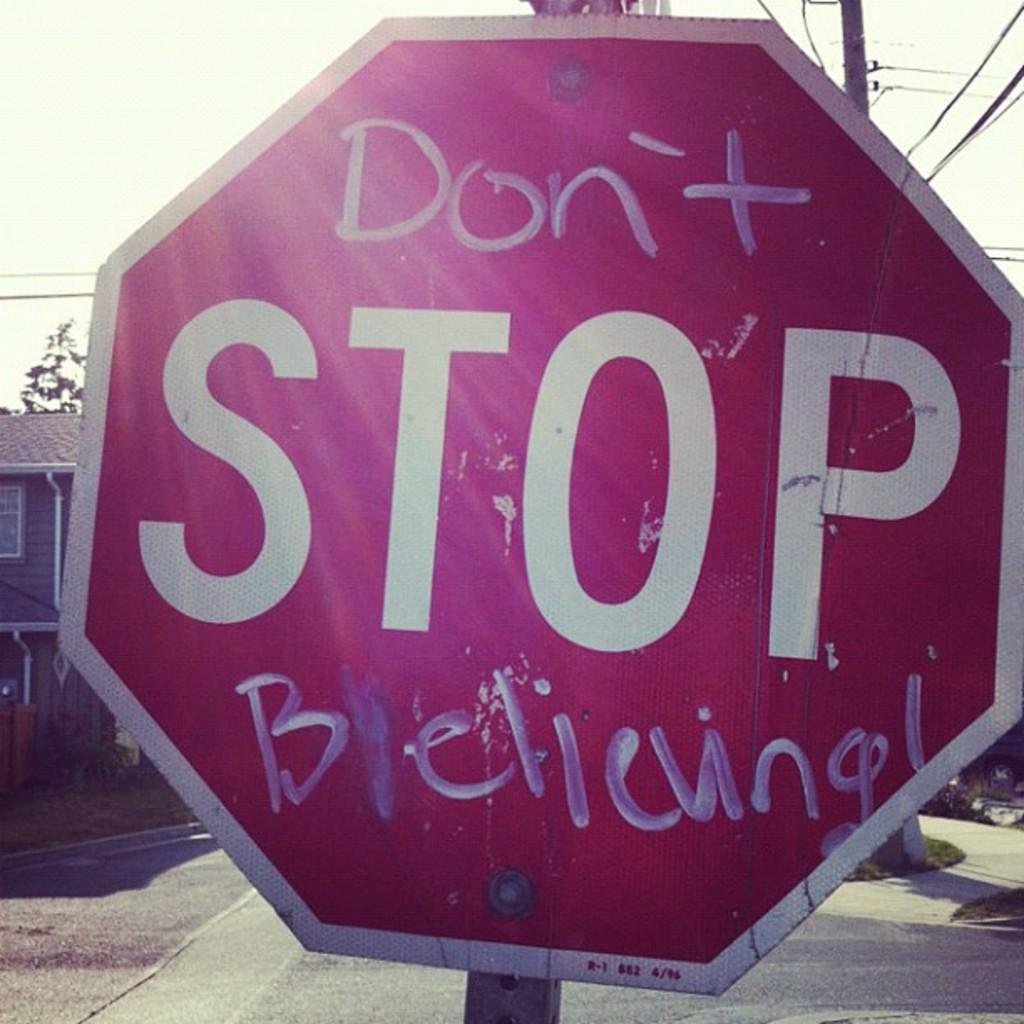Provide a one-sentence caption for the provided image. The Stop sign has been written on by someone so it reads 'Don't Stop Believing!". 